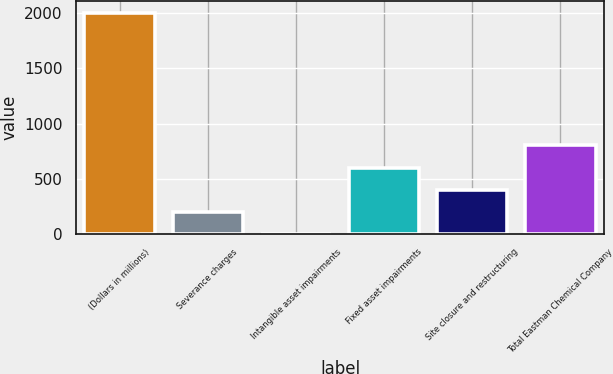Convert chart. <chart><loc_0><loc_0><loc_500><loc_500><bar_chart><fcel>(Dollars in millions)<fcel>Severance charges<fcel>Intangible asset impairments<fcel>Fixed asset impairments<fcel>Site closure and restructuring<fcel>Total Eastman Chemical Company<nl><fcel>2006<fcel>201.5<fcel>1<fcel>602.5<fcel>402<fcel>803<nl></chart> 